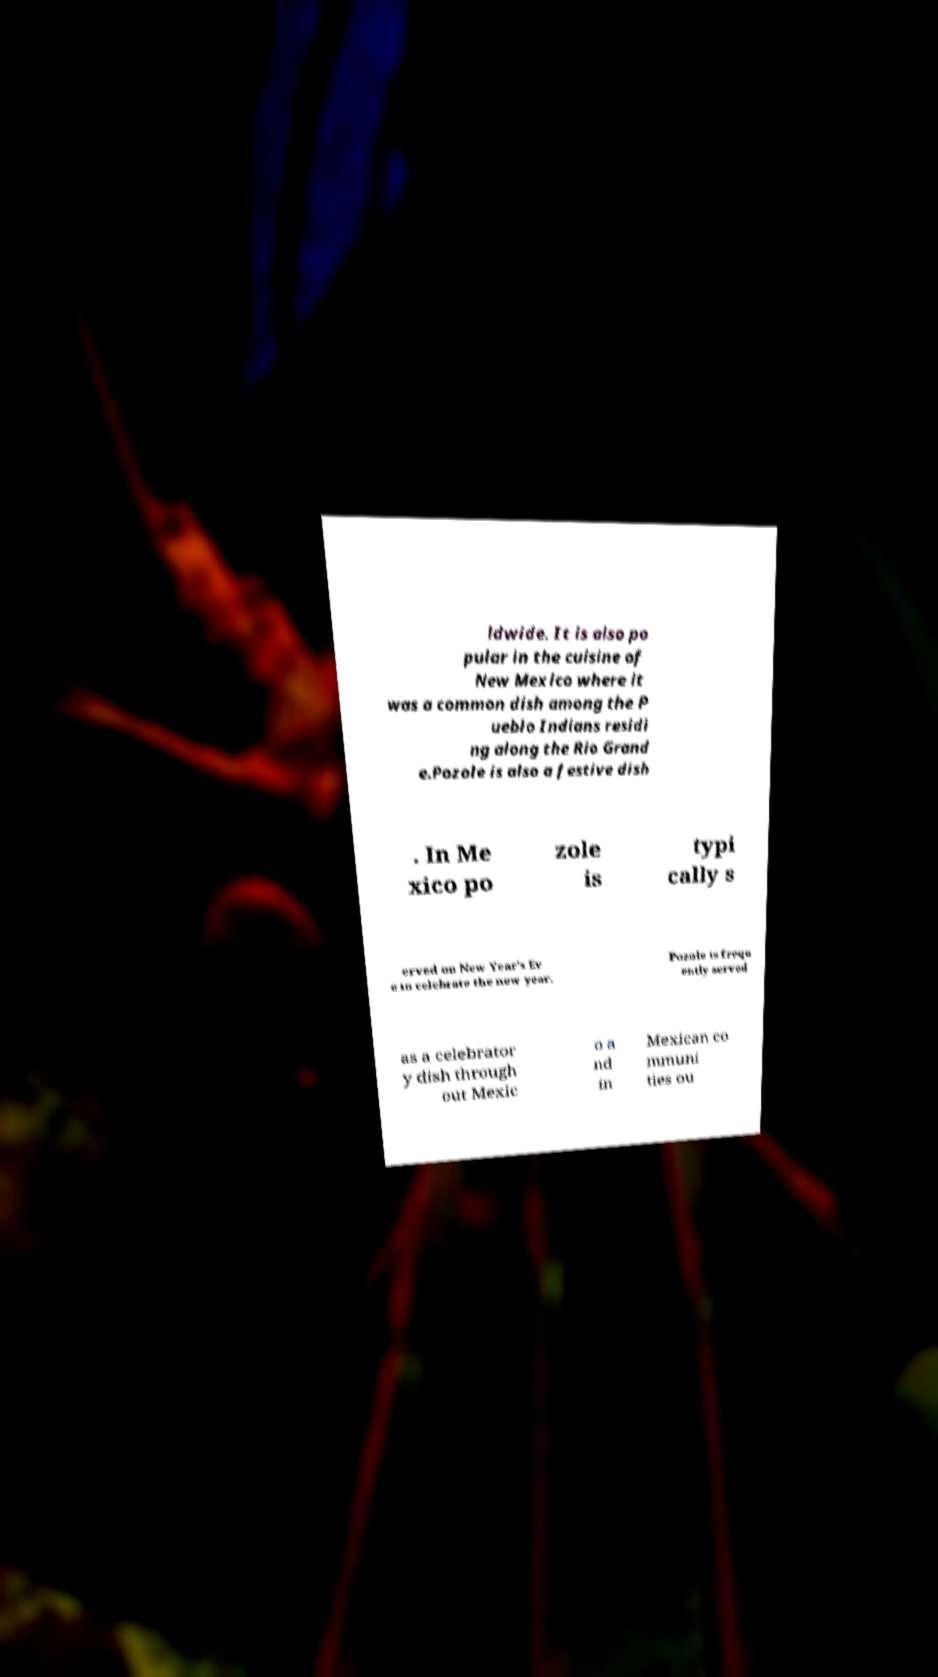I need the written content from this picture converted into text. Can you do that? ldwide. It is also po pular in the cuisine of New Mexico where it was a common dish among the P ueblo Indians residi ng along the Rio Grand e.Pozole is also a festive dish . In Me xico po zole is typi cally s erved on New Year's Ev e to celebrate the new year. Pozole is frequ ently served as a celebrator y dish through out Mexic o a nd in Mexican co mmuni ties ou 